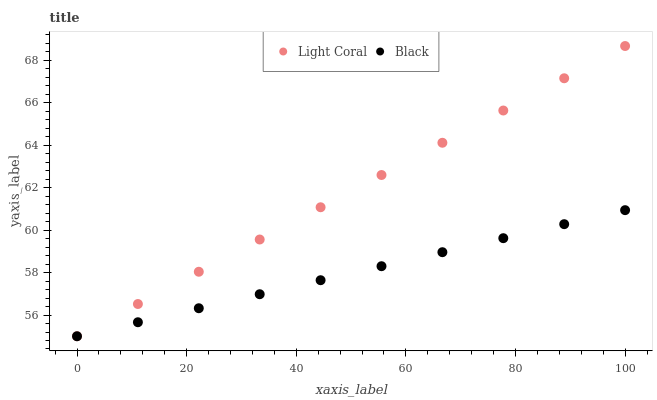Does Black have the minimum area under the curve?
Answer yes or no. Yes. Does Light Coral have the maximum area under the curve?
Answer yes or no. Yes. Does Black have the maximum area under the curve?
Answer yes or no. No. Is Black the smoothest?
Answer yes or no. Yes. Is Light Coral the roughest?
Answer yes or no. Yes. Is Black the roughest?
Answer yes or no. No. Does Light Coral have the lowest value?
Answer yes or no. Yes. Does Light Coral have the highest value?
Answer yes or no. Yes. Does Black have the highest value?
Answer yes or no. No. Does Black intersect Light Coral?
Answer yes or no. Yes. Is Black less than Light Coral?
Answer yes or no. No. Is Black greater than Light Coral?
Answer yes or no. No. 